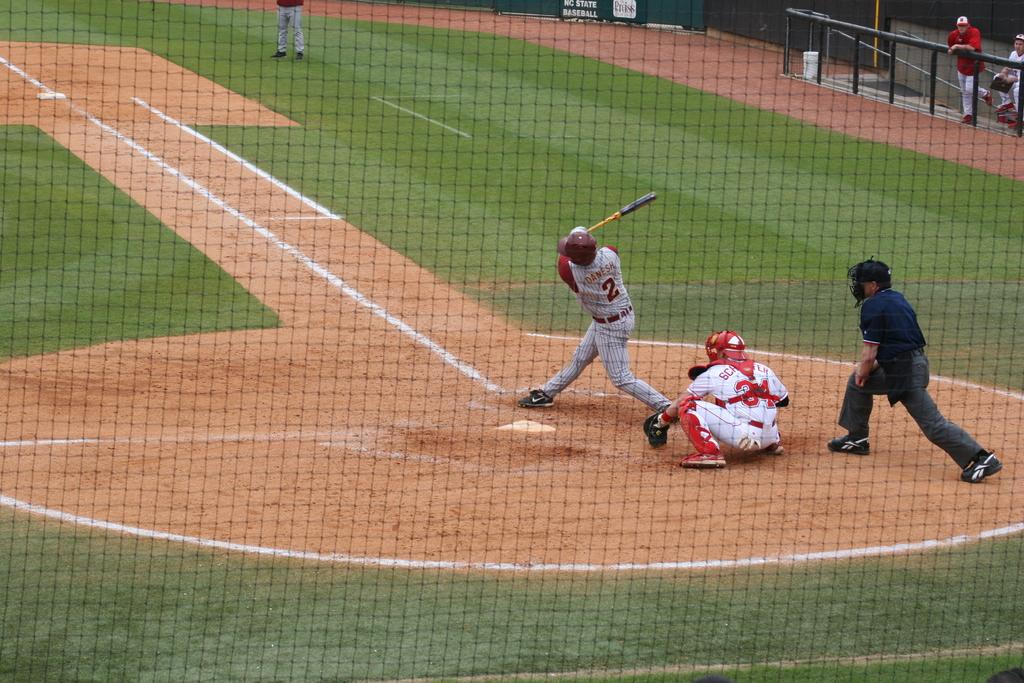What is the main feature of the image? The main feature of the image is a fence. What activity is taking place in the image? People are playing cricket on the ground. Can you describe the people holding the fence? There are two people holding the metal fence on the right side of the image. What type of sofa can be seen in the image? There is no sofa present in the image. Can you describe the bloodstains on the fence in the image? There are no bloodstains visible on the fence in the image. 